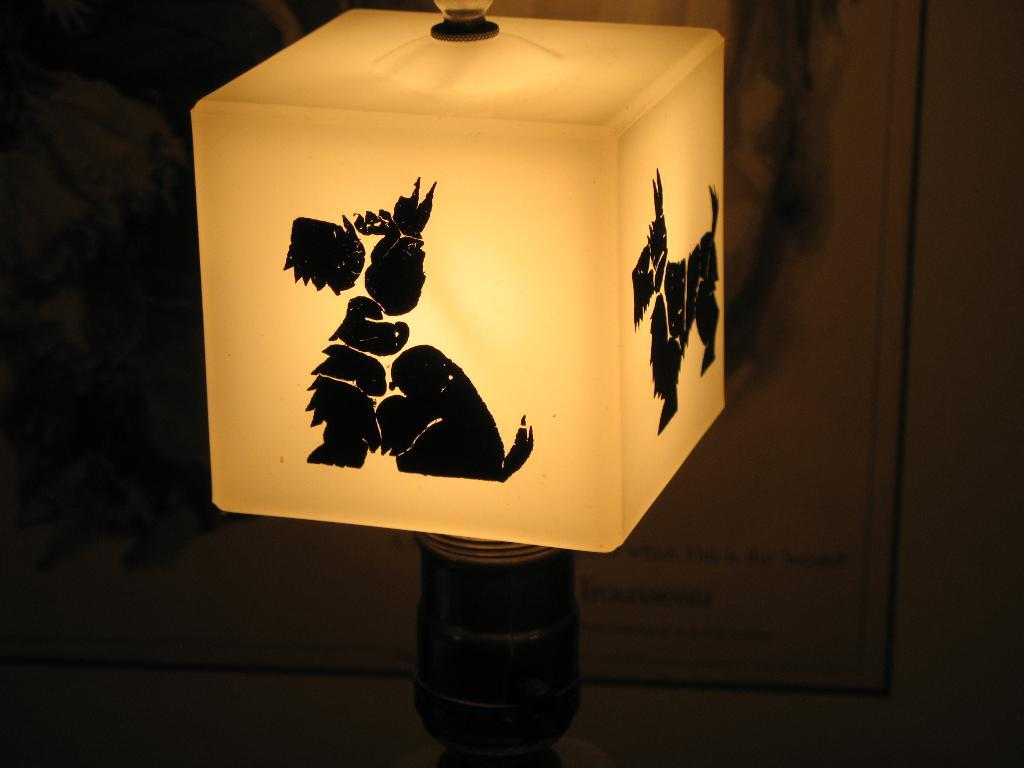What shape is the lamp in the image? The lamp in the image is square-shaped. What design is featured on the lamp? The lamp has a dog image on it. What can be seen in the background of the image? There appears to be a door in the background of the image. What type of neck accessory is hanging from the lamp in the image? There is no neck accessory present in the image; it features a square-shaped lamp with a dog image on it and a door in the background. 